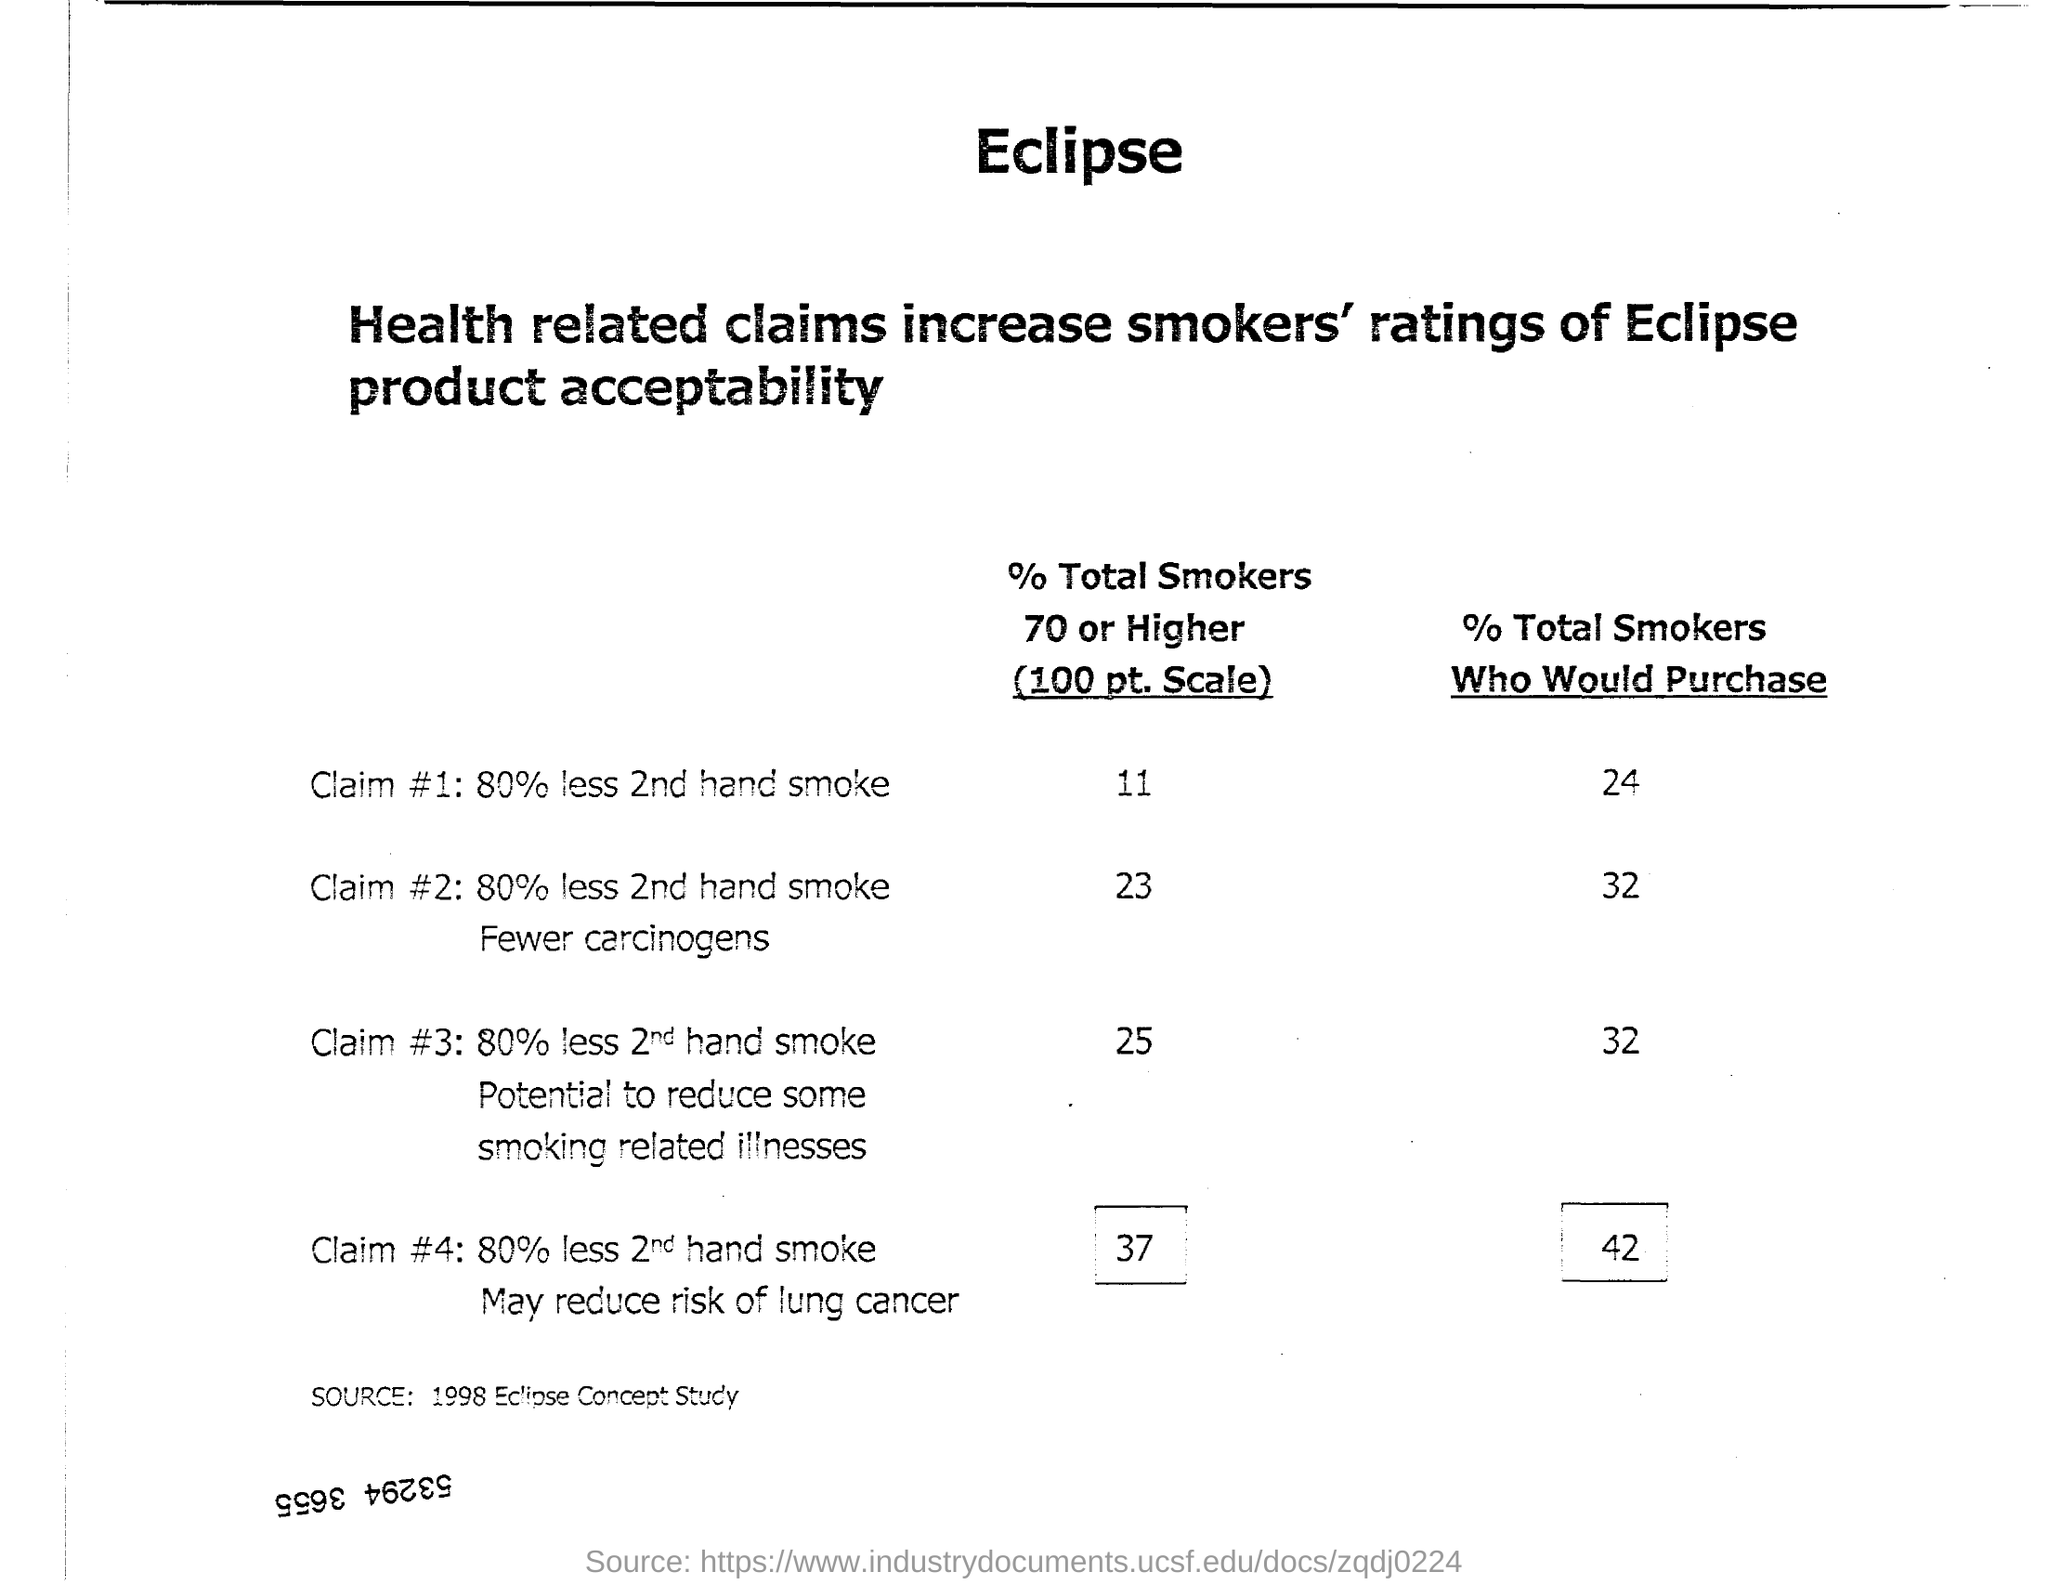Mention a couple of crucial points in this snapshot. The inclusion of health-related claims in Eclipse product acceptability increases ratings among smokers. The data was obtained from a 1998 Eclipse Concept Study. Of all the claims, Claim #1 has the lowest percentage of smokers 70 or older, with 80% fewer second-hand smoke exposure. 